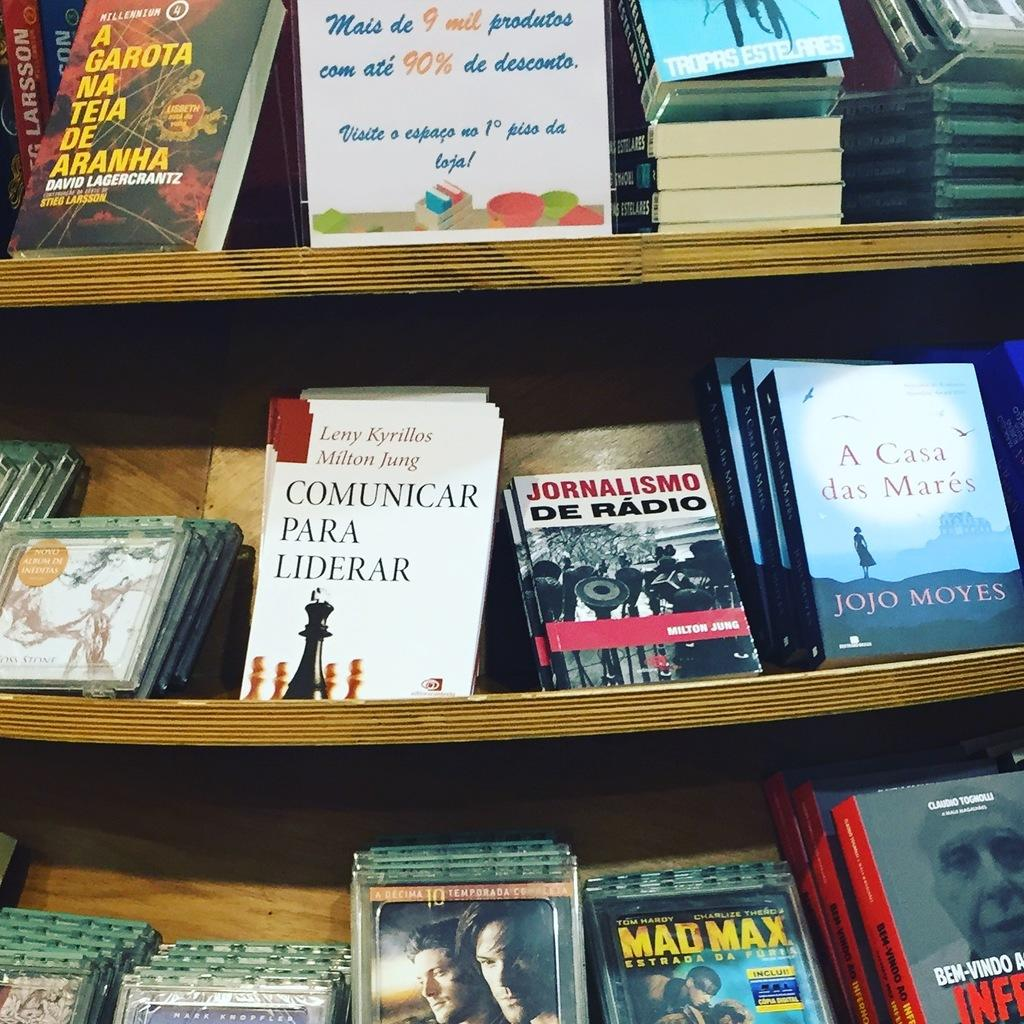Provide a one-sentence caption for the provided image. The movie Mad Max sits on a bottom shelf at some kind of store. 